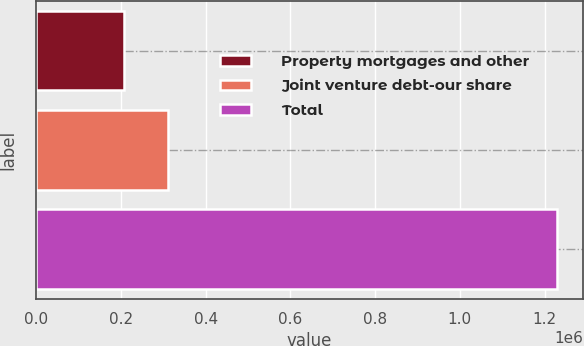Convert chart to OTSL. <chart><loc_0><loc_0><loc_500><loc_500><bar_chart><fcel>Property mortgages and other<fcel>Joint venture debt-our share<fcel>Total<nl><fcel>208017<fcel>310098<fcel>1.22883e+06<nl></chart> 